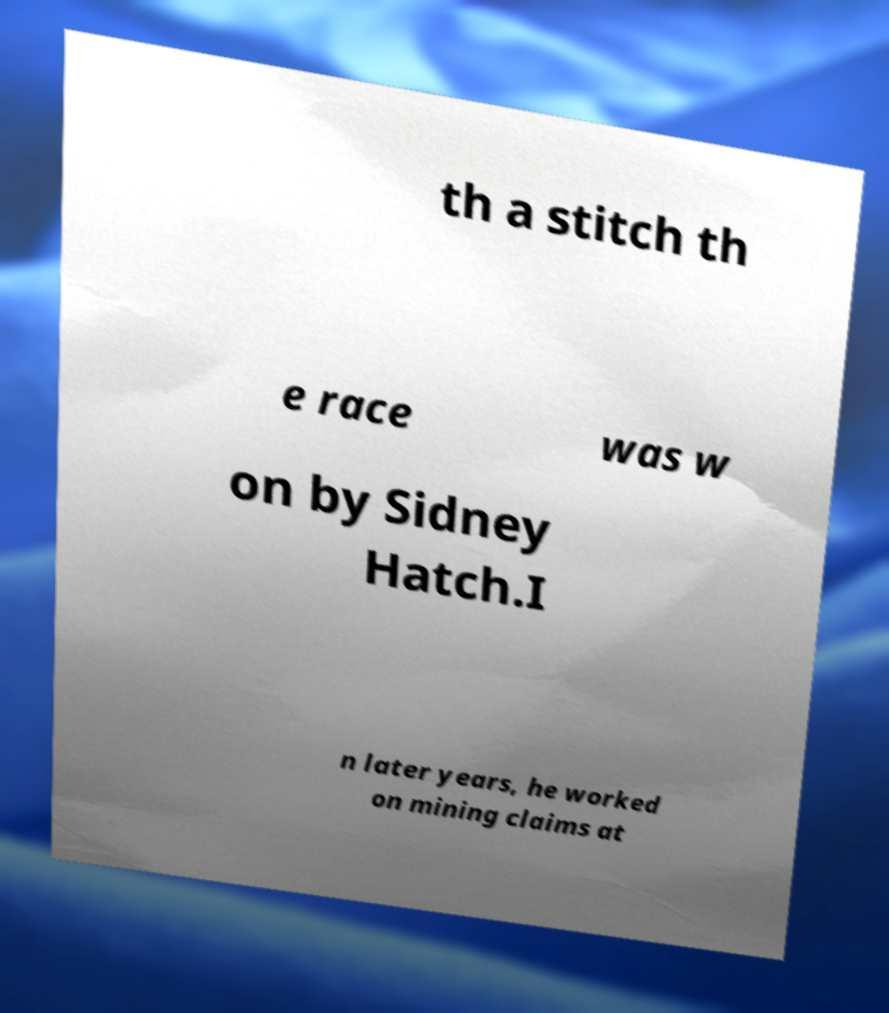Could you extract and type out the text from this image? th a stitch th e race was w on by Sidney Hatch.I n later years, he worked on mining claims at 